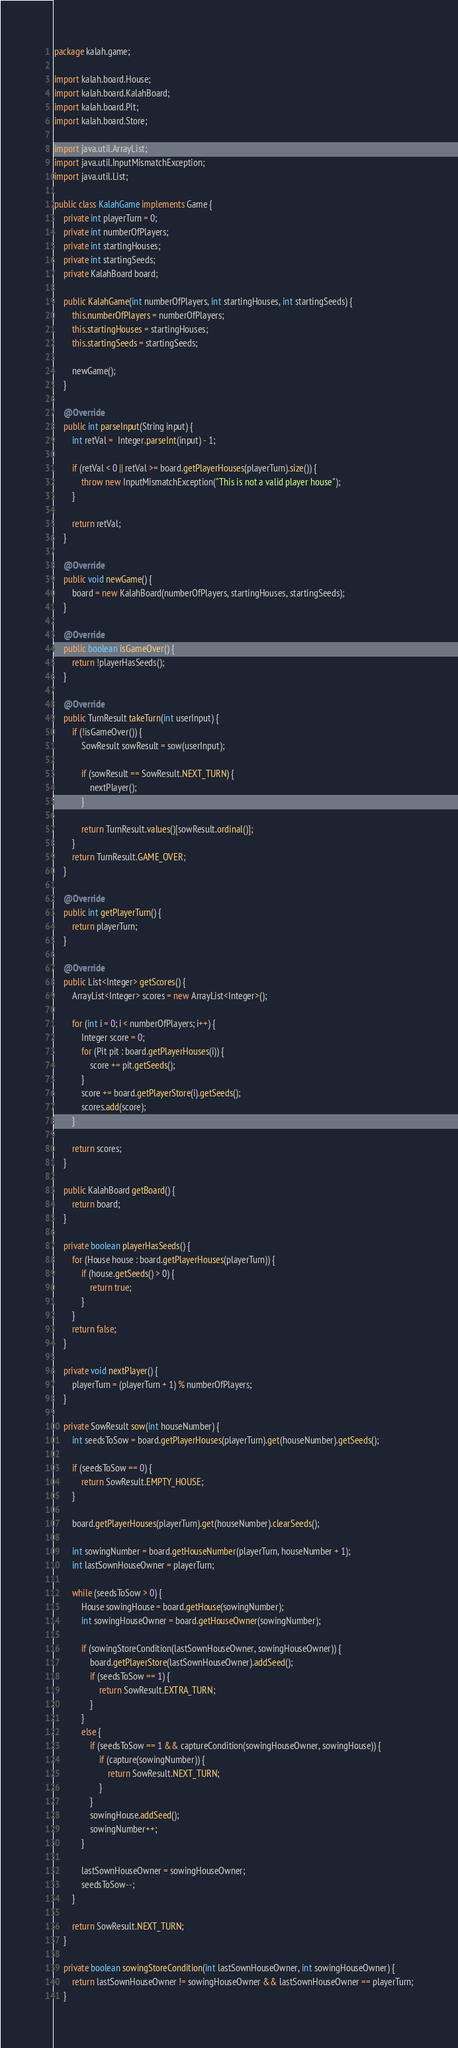Convert code to text. <code><loc_0><loc_0><loc_500><loc_500><_Java_>package kalah.game;

import kalah.board.House;
import kalah.board.KalahBoard;
import kalah.board.Pit;
import kalah.board.Store;

import java.util.ArrayList;
import java.util.InputMismatchException;
import java.util.List;

public class KalahGame implements Game {
    private int playerTurn = 0;
    private int numberOfPlayers;
    private int startingHouses;
    private int startingSeeds;
    private KalahBoard board;

    public KalahGame(int numberOfPlayers, int startingHouses, int startingSeeds) {
        this.numberOfPlayers = numberOfPlayers;
        this.startingHouses = startingHouses;
        this.startingSeeds = startingSeeds;

        newGame();
    }

    @Override
    public int parseInput(String input) {
        int retVal =  Integer.parseInt(input) - 1;

        if (retVal < 0 || retVal >= board.getPlayerHouses(playerTurn).size()) {
            throw new InputMismatchException("This is not a valid player house");
        }

        return retVal;
    }

    @Override
    public void newGame() {
        board = new KalahBoard(numberOfPlayers, startingHouses, startingSeeds);
    }

    @Override
    public boolean isGameOver() {
        return !playerHasSeeds();
    }

    @Override
    public TurnResult takeTurn(int userInput) {
        if (!isGameOver()) {
            SowResult sowResult = sow(userInput);

            if (sowResult == SowResult.NEXT_TURN) {
                nextPlayer();
            }

            return TurnResult.values()[sowResult.ordinal()];
        }
        return TurnResult.GAME_OVER;
    }

    @Override
    public int getPlayerTurn() {
        return playerTurn;
    }

    @Override
    public List<Integer> getScores() {
        ArrayList<Integer> scores = new ArrayList<Integer>();

        for (int i = 0; i < numberOfPlayers; i++) {
            Integer score = 0;
            for (Pit pit : board.getPlayerHouses(i)) {
                score += pit.getSeeds();
            }
            score += board.getPlayerStore(i).getSeeds();
            scores.add(score);
        }

        return scores;
    }

    public KalahBoard getBoard() {
        return board;
    }

    private boolean playerHasSeeds() {
        for (House house : board.getPlayerHouses(playerTurn)) {
            if (house.getSeeds() > 0) {
                return true;
            }
        }
        return false;
    }

    private void nextPlayer() {
        playerTurn = (playerTurn + 1) % numberOfPlayers;
    }

    private SowResult sow(int houseNumber) {
        int seedsToSow = board.getPlayerHouses(playerTurn).get(houseNumber).getSeeds();

        if (seedsToSow == 0) {
            return SowResult.EMPTY_HOUSE;
        }

        board.getPlayerHouses(playerTurn).get(houseNumber).clearSeeds();

        int sowingNumber = board.getHouseNumber(playerTurn, houseNumber + 1);
        int lastSownHouseOwner = playerTurn;

        while (seedsToSow > 0) {
            House sowingHouse = board.getHouse(sowingNumber);
            int sowingHouseOwner = board.getHouseOwner(sowingNumber);

            if (sowingStoreCondition(lastSownHouseOwner, sowingHouseOwner)) {
                board.getPlayerStore(lastSownHouseOwner).addSeed();
                if (seedsToSow == 1) {
                    return SowResult.EXTRA_TURN;
                }
            }
            else {
                if (seedsToSow == 1 && captureCondition(sowingHouseOwner, sowingHouse)) {
                    if (capture(sowingNumber)) {
                        return SowResult.NEXT_TURN;
                    }
                }
                sowingHouse.addSeed();
                sowingNumber++;
            }

            lastSownHouseOwner = sowingHouseOwner;
            seedsToSow--;
        }

        return SowResult.NEXT_TURN;
    }

    private boolean sowingStoreCondition(int lastSownHouseOwner, int sowingHouseOwner) {
        return lastSownHouseOwner != sowingHouseOwner && lastSownHouseOwner == playerTurn;
    }
</code> 